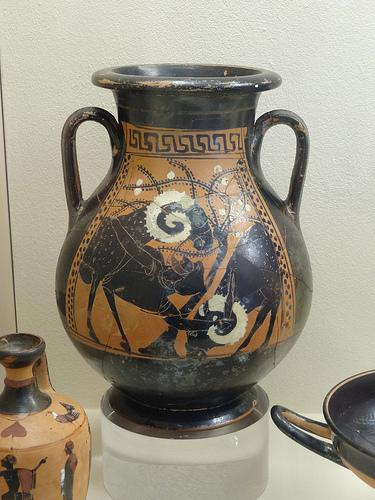Question: what has two handles?
Choices:
A. A bike.
B. The drawer.
C. The pot.
D. The cup.
Answer with the letter. Answer: C Question: how many pots are pictured?
Choices:
A. One.
B. Three.
C. Four.
D. Two.
Answer with the letter. Answer: B Question: where are the pots?
Choices:
A. Under the sink.
B. On the shelf.
C. In the sink.
D. On the stove.
Answer with the letter. Answer: B Question: who is in the photo?
Choices:
A. Nobody.
B. A family.
C. A couple.
D. A baby.
Answer with the letter. Answer: A Question: why are the pots on a shelf?
Choices:
A. To use to cook.
B. For watering plants.
C. For display.
D. To put in storage.
Answer with the letter. Answer: C 